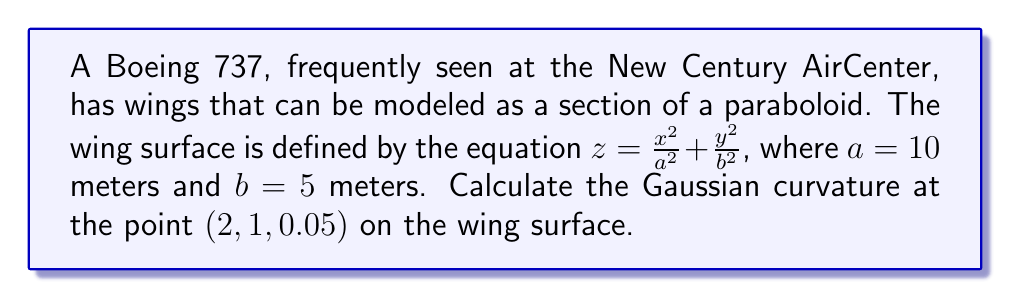Teach me how to tackle this problem. To compute the Gaussian curvature of the aircraft wing, we'll follow these steps:

1) The Gaussian curvature $K$ is given by $K = \frac{LN - M^2}{EG - F^2}$, where $E$, $F$, $G$ are the coefficients of the first fundamental form, and $L$, $M$, $N$ are the coefficients of the second fundamental form.

2) First, let's calculate the partial derivatives:
   
   $z_x = \frac{2x}{a^2} = \frac{x}{50}$
   
   $z_y = \frac{2y}{b^2} = \frac{y}{12.5}$
   
   $z_{xx} = \frac{2}{a^2} = \frac{1}{50}$
   
   $z_{yy} = \frac{2}{b^2} = \frac{1}{12.5}$
   
   $z_{xy} = 0$

3) Now, we can calculate $E$, $F$, and $G$:
   
   $E = 1 + z_x^2 = 1 + (\frac{x}{50})^2$
   
   $F = z_x z_y = \frac{xy}{625}$
   
   $G = 1 + z_y^2 = 1 + (\frac{y}{12.5})^2$

4) Next, we calculate $L$, $M$, and $N$:
   
   $L = \frac{z_{xx}}{\sqrt{1 + z_x^2 + z_y^2}} = \frac{1/50}{\sqrt{1 + (x/50)^2 + (y/12.5)^2}}$
   
   $M = \frac{z_{xy}}{\sqrt{1 + z_x^2 + z_y^2}} = 0$
   
   $N = \frac{z_{yy}}{\sqrt{1 + z_x^2 + z_y^2}} = \frac{1/12.5}{\sqrt{1 + (x/50)^2 + (y/12.5)^2}}$

5) Now we can substitute the point $(2, 1, 0.05)$ into these expressions:
   
   $E = 1 + (\frac{2}{50})^2 = 1.0016$
   
   $F = \frac{2 \cdot 1}{625} = 0.0032$
   
   $G = 1 + (\frac{1}{12.5})^2 = 1.0064$
   
   $L = \frac{1/50}{\sqrt{1 + (2/50)^2 + (1/12.5)^2}} = 0.0199$
   
   $M = 0$
   
   $N = \frac{1/12.5}{\sqrt{1 + (2/50)^2 + (1/12.5)^2}} = 0.0796$

6) Finally, we can calculate the Gaussian curvature:

   $K = \frac{LN - M^2}{EG - F^2} = \frac{0.0199 \cdot 0.0796 - 0^2}{1.0016 \cdot 1.0064 - 0.0032^2} = 0.001581$

Therefore, the Gaussian curvature at the point $(2, 1, 0.05)$ on the wing surface is approximately 0.001581 m^(-2).
Answer: $K \approx 0.001581 \text{ m}^{-2}$ 